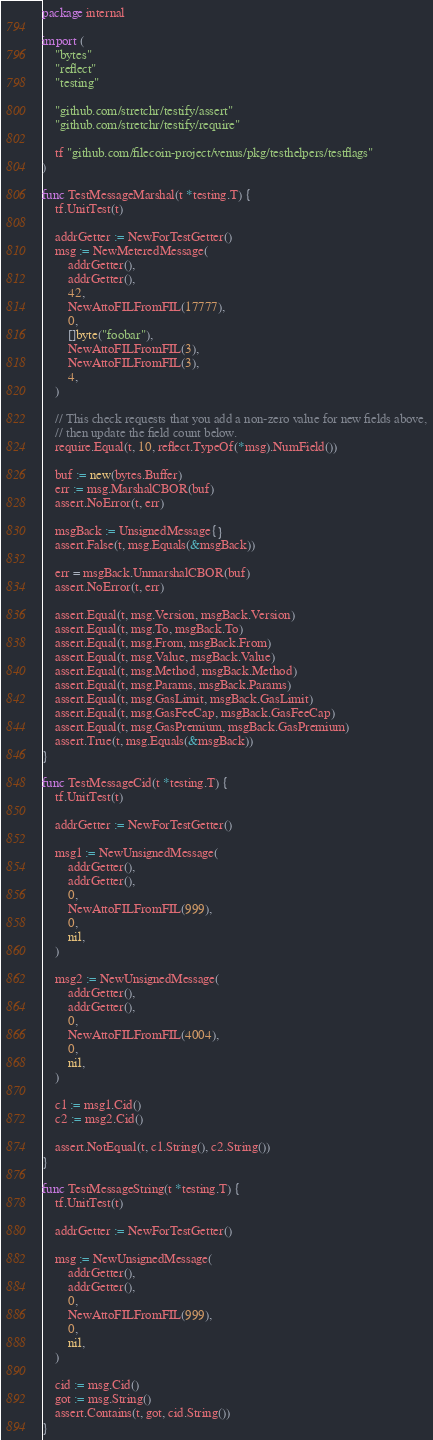<code> <loc_0><loc_0><loc_500><loc_500><_Go_>package internal

import (
	"bytes"
	"reflect"
	"testing"

	"github.com/stretchr/testify/assert"
	"github.com/stretchr/testify/require"

	tf "github.com/filecoin-project/venus/pkg/testhelpers/testflags"
)

func TestMessageMarshal(t *testing.T) {
	tf.UnitTest(t)

	addrGetter := NewForTestGetter()
	msg := NewMeteredMessage(
		addrGetter(),
		addrGetter(),
		42,
		NewAttoFILFromFIL(17777),
		0,
		[]byte("foobar"),
		NewAttoFILFromFIL(3),
		NewAttoFILFromFIL(3),
		4,
	)

	// This check requests that you add a non-zero value for new fields above,
	// then update the field count below.
	require.Equal(t, 10, reflect.TypeOf(*msg).NumField())

	buf := new(bytes.Buffer)
	err := msg.MarshalCBOR(buf)
	assert.NoError(t, err)

	msgBack := UnsignedMessage{}
	assert.False(t, msg.Equals(&msgBack))

	err = msgBack.UnmarshalCBOR(buf)
	assert.NoError(t, err)

	assert.Equal(t, msg.Version, msgBack.Version)
	assert.Equal(t, msg.To, msgBack.To)
	assert.Equal(t, msg.From, msgBack.From)
	assert.Equal(t, msg.Value, msgBack.Value)
	assert.Equal(t, msg.Method, msgBack.Method)
	assert.Equal(t, msg.Params, msgBack.Params)
	assert.Equal(t, msg.GasLimit, msgBack.GasLimit)
	assert.Equal(t, msg.GasFeeCap, msgBack.GasFeeCap)
	assert.Equal(t, msg.GasPremium, msgBack.GasPremium)
	assert.True(t, msg.Equals(&msgBack))
}

func TestMessageCid(t *testing.T) {
	tf.UnitTest(t)

	addrGetter := NewForTestGetter()

	msg1 := NewUnsignedMessage(
		addrGetter(),
		addrGetter(),
		0,
		NewAttoFILFromFIL(999),
		0,
		nil,
	)

	msg2 := NewUnsignedMessage(
		addrGetter(),
		addrGetter(),
		0,
		NewAttoFILFromFIL(4004),
		0,
		nil,
	)

	c1 := msg1.Cid()
	c2 := msg2.Cid()

	assert.NotEqual(t, c1.String(), c2.String())
}

func TestMessageString(t *testing.T) {
	tf.UnitTest(t)

	addrGetter := NewForTestGetter()

	msg := NewUnsignedMessage(
		addrGetter(),
		addrGetter(),
		0,
		NewAttoFILFromFIL(999),
		0,
		nil,
	)

	cid := msg.Cid()
	got := msg.String()
	assert.Contains(t, got, cid.String())
}
</code> 